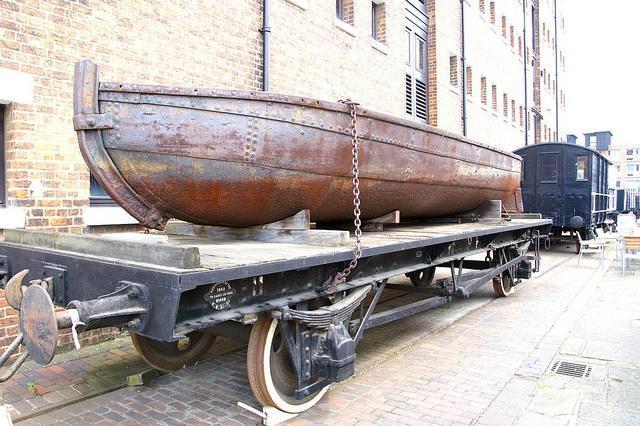Does the description: "The boat is parallel to the dining table." accurately reflect the image?
Answer yes or no. No. Evaluate: Does the caption "The dining table is in front of the boat." match the image?
Answer yes or no. No. 